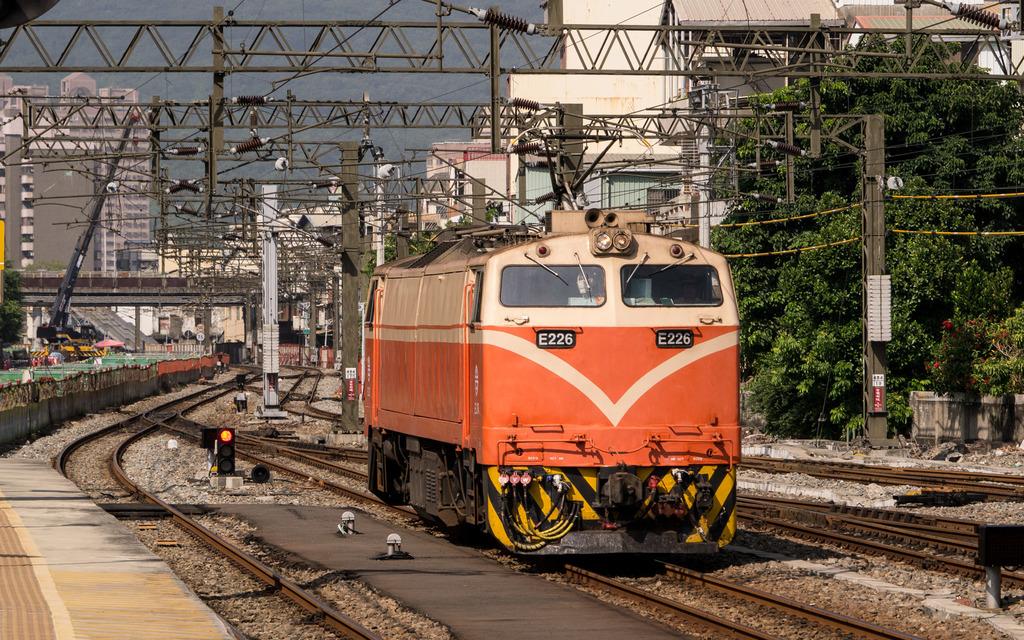What letters and numbers are on the front of the train?
Keep it short and to the point. E226. 